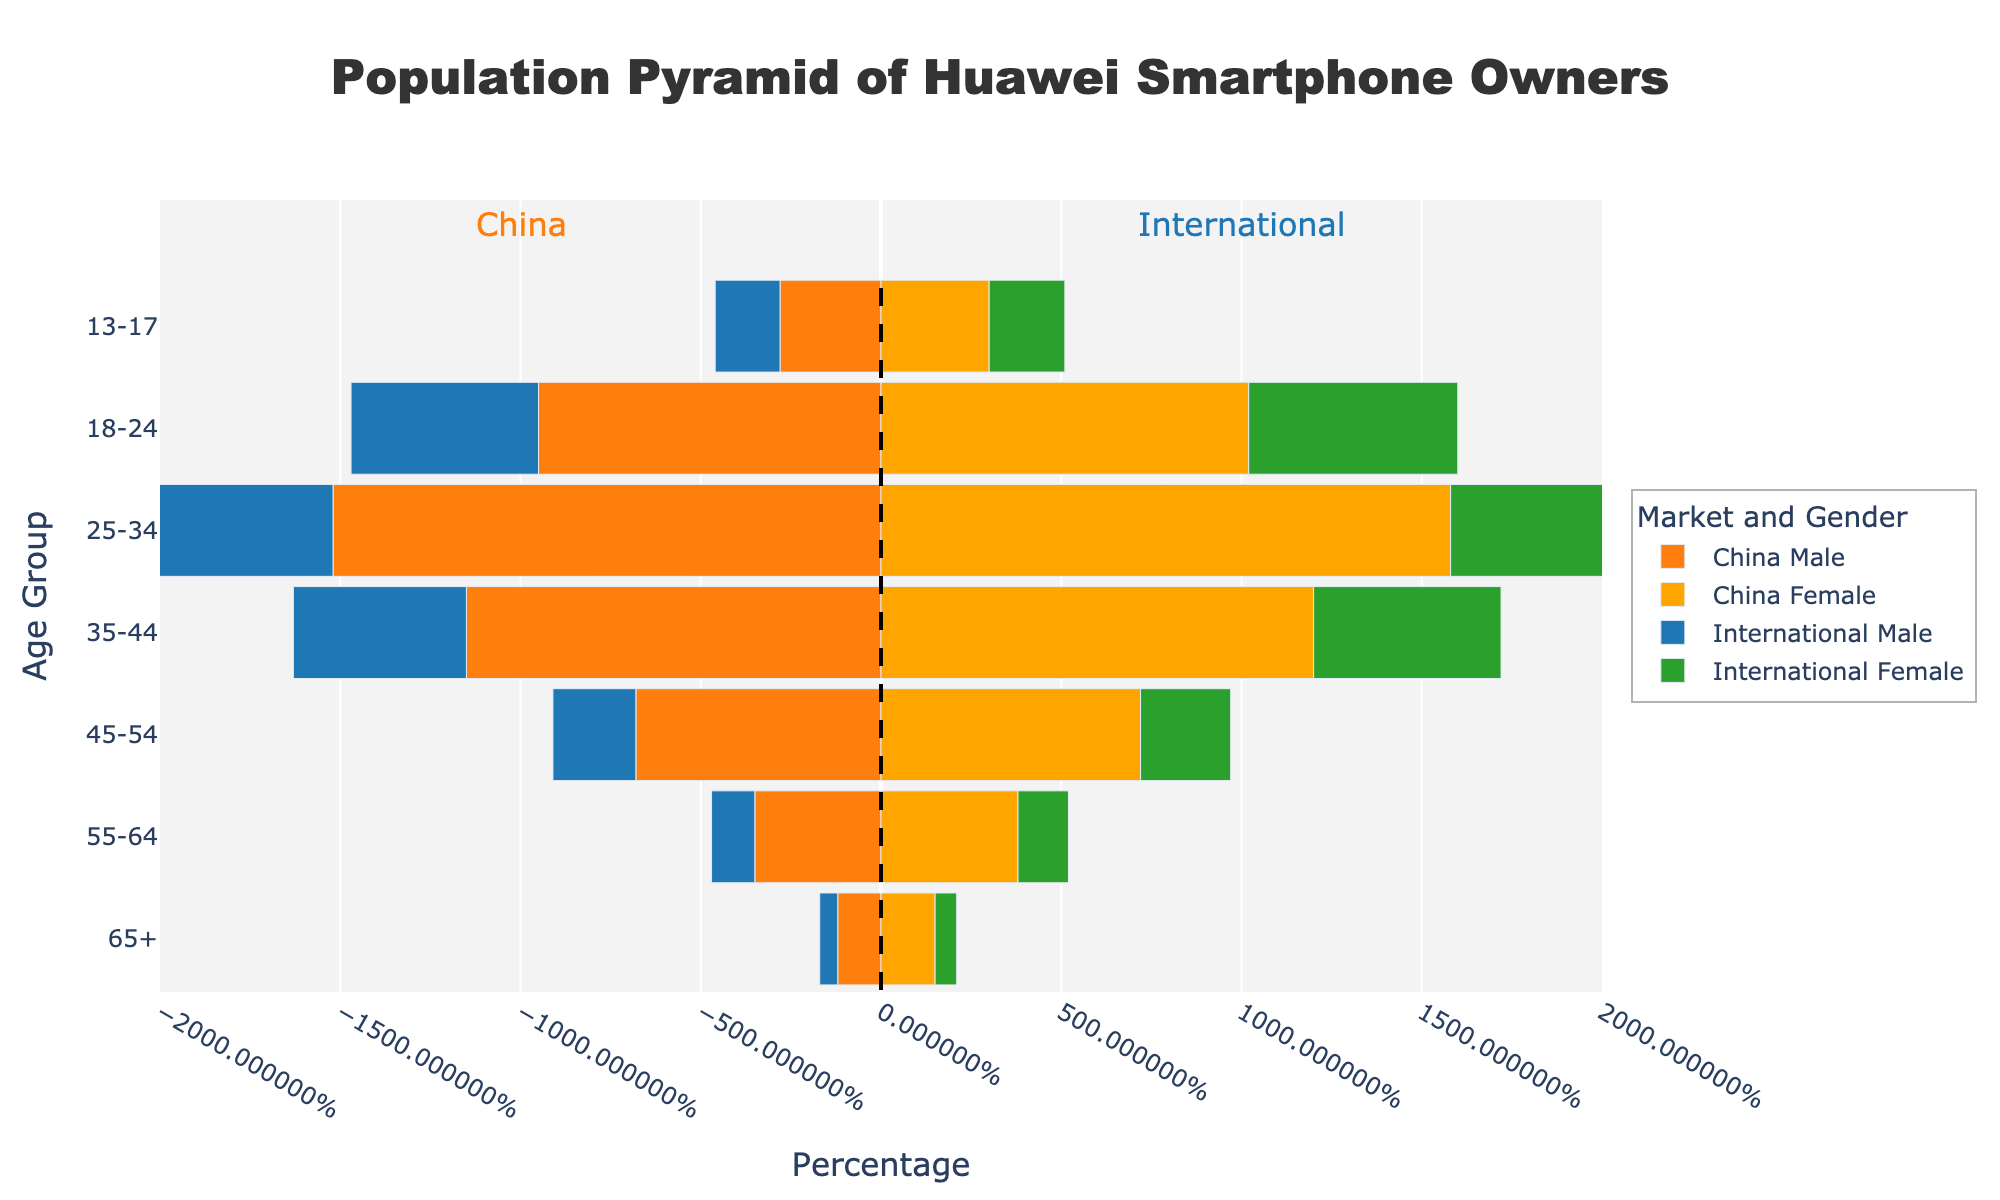What is the title of the figure? The title is located at the top of the figure and is typically used to describe the content of the plot. In this case, it should match the string set in the code for the title.
Answer: Population Pyramid of Huawei Smartphone Owners Which age group has the highest percentage of smartphone owners in China? To determine this, look at the length of the bars for both males and females in each age group on the Chinese side of the population pyramid. The longest bars indicate the highest percentage.
Answer: 25-34 Are international male owners generally younger or older compared to Chinese male owners? Compare the distribution of the bars for international males to those for Chinese males across all age groups. Notice which side has the longer bars for younger or older age groups.
Answer: Younger In the 35-44 age group, how does the percentage of Chinese female owners compare to international female owners? Identify the bars for both Chinese and international females in the 35-44 age range. Compare their lengths directly to see which one is longer.
Answer: Higher Which gender has a higher percentage in the 18-24 age group internationally? Look at the lengths of the bars corresponding to international males and females in the 18-24 age group to see which one extends further.
Answer: Female By how much does the percentage of Chinese female owners in the 45-54 age group exceed that of international female owners in the same group? Subtract the percentage of international female owners (2.5) from the percentage of Chinese female owners (7.2) in the 45-54 age group.
Answer: 4.7 What percentage of Chinese male owners are in the 55-64 age group? Locate the bar corresponding to Chinese males in the 55-64 age group and note its length.
Answer: 3.5 In which age group are the international male owners the least represented? Identify the shortest bar on the international male side of the population pyramid to determine the age group with the smallest percentage.
Answer: 65+ How do the distributions of the 25-34 age group compare between Chinese and international markets? Examine the lengths of the bars for both males and females in the 25-34 age range for both Chinese and international markets. Compare which set of bars is longer.
Answer: Higher in China 